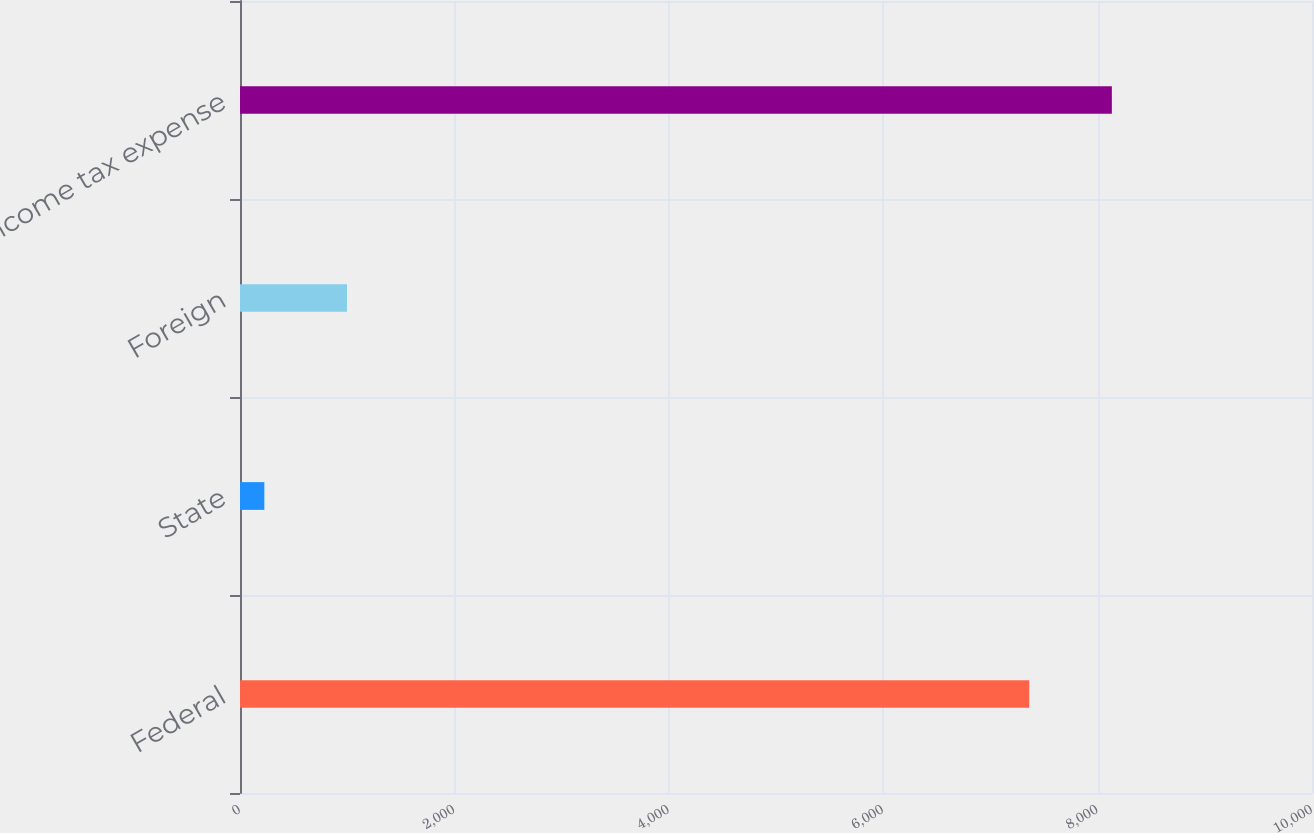<chart> <loc_0><loc_0><loc_500><loc_500><bar_chart><fcel>Federal<fcel>State<fcel>Foreign<fcel>Income tax expense<nl><fcel>7362<fcel>227<fcel>998<fcel>8133<nl></chart> 